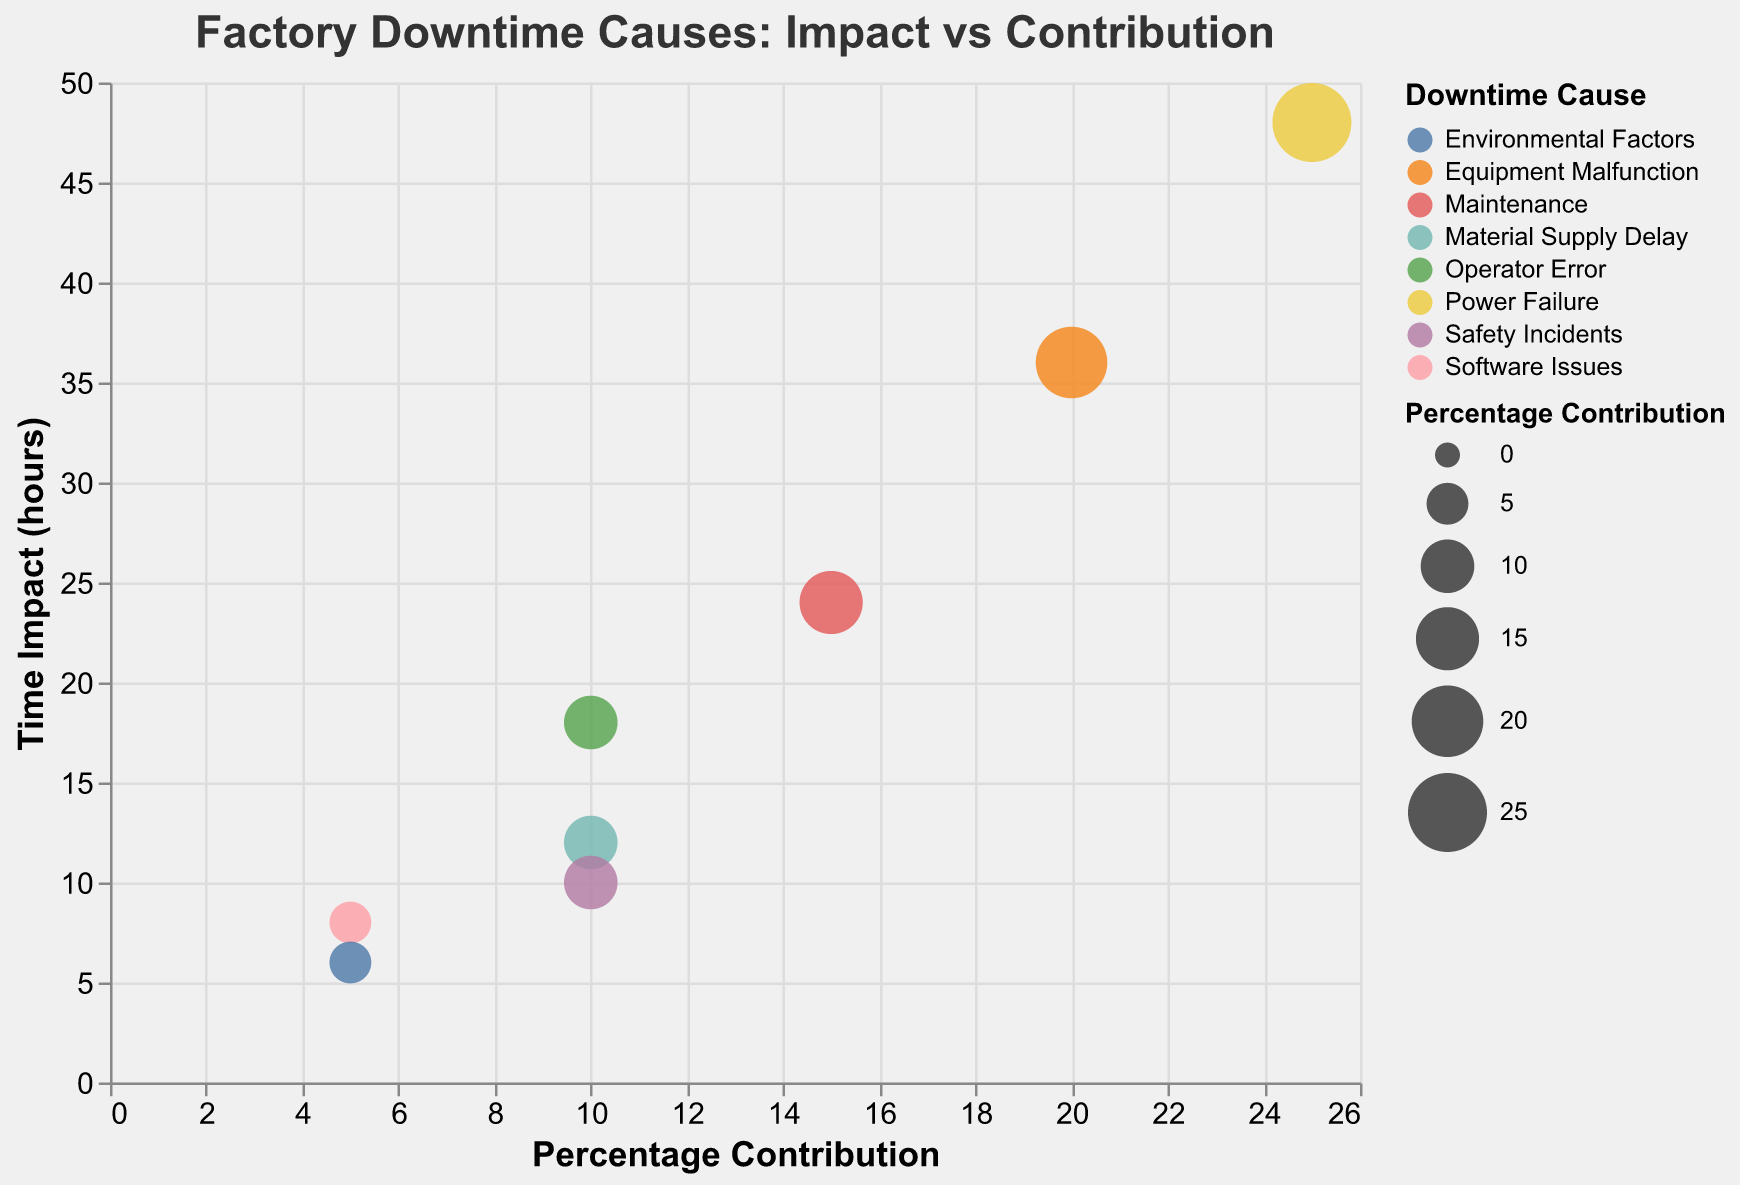What is the title of the chart? The chart title is written at the top of the chart and it is usually straightforward to locate it visually.
Answer: Factory Downtime Causes: Impact vs Contribution How many causes of factory downtime are represented in the chart? Each bubble represents a different cause of factory downtime. By counting the distinct bubbles (one for each cause), we can determine the number of causes.
Answer: 8 Which downtime cause has the highest percentage contribution? By observing the x-axis (Percentage Contribution) and identifying the bubble farthest to the right, we find the cause with the highest contribution.
Answer: Power Failure What is the relationship between 'Equipment Malfunction' and 'Maintenance' in terms of Time Impact? By comparing the y-axis values for 'Equipment Malfunction' and 'Maintenance', we see that 'Equipment Malfunction' has a higher Time Impact.
Answer: 'Equipment Malfunction' has higher Time Impact than 'Maintenance' What is the combined percentage contribution of 'Operator Error', 'Material Supply Delay', and 'Safety Incidents'? By adding the Percentage Contribution of 'Operator Error' (10), 'Material Supply Delay' (10), and 'Safety Incidents' (10), we can find the combined percentage contribution.
Answer: 30 Which downtime cause has the lowest Time Impact? By looking at the y-axis (Time Impact, in hours) and finding the bubble positioned lowest on this axis, we can identify the cause with the lowest impact.
Answer: Environmental Factors How do 'Software Issues' and 'Environmental Factors' compare in terms of both Percentage Contribution and Time Impact? By examining both the x-axis and y-axis for 'Software Issues' and 'Environmental Factors', we can compare their positions relative to each contribution and impact. 'Software Issues' has a higher Time Impact and the same Percentage Contribution compared to 'Environmental Factors'.
Answer: 'Software Issues' has higher Time Impact, same Percentage Contribution compared to 'Environmental Factors' What is the average Time Impact of all downtime causes? To determine the average Time Impact, sum all the Time Impact values and divide by the number of causes: (48 + 36 + 24 + 18 + 12 + 10 + 8 + 6) / 8. (162 / 8).
Answer: 20.25 hours Which downtime cause contributes more: 'Maintenance' or 'Operator Error'? By examining the x-axis values (Percentage Contribution) of 'Maintenance' and 'Operator Error', we find that 'Maintenance' has a higher contribution.
Answer: Maintenance If we wanted to focus on minimizing downtime with the least effort, which cause should we prioritize given its high contribution but low Time Impact? By looking for a cause with a high Percentage Contribution but relatively low Time Impact, we can identify 'Operator Error' as a potential priority.
Answer: Operator Error 